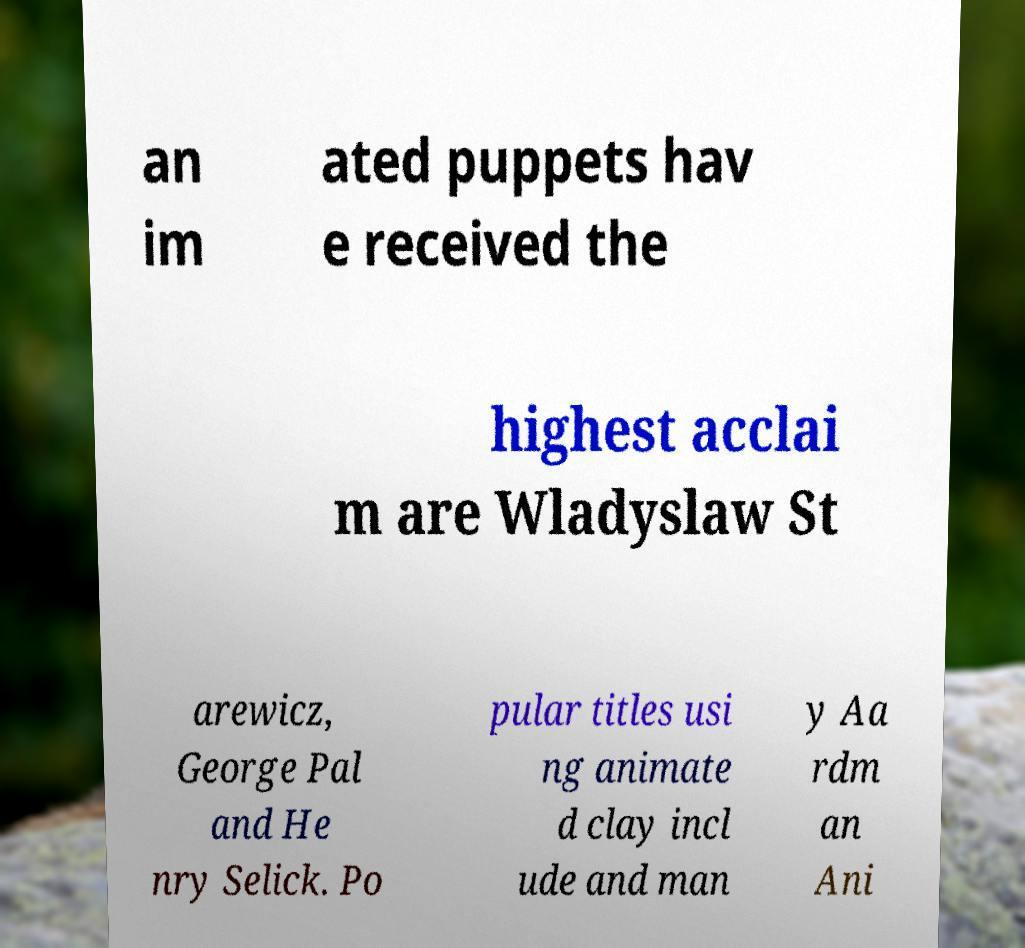There's text embedded in this image that I need extracted. Can you transcribe it verbatim? an im ated puppets hav e received the highest acclai m are Wladyslaw St arewicz, George Pal and He nry Selick. Po pular titles usi ng animate d clay incl ude and man y Aa rdm an Ani 